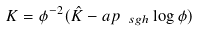<formula> <loc_0><loc_0><loc_500><loc_500>K = \phi ^ { - 2 } ( \hat { K } - \sl a p _ { \ s g h } \log \phi )</formula> 